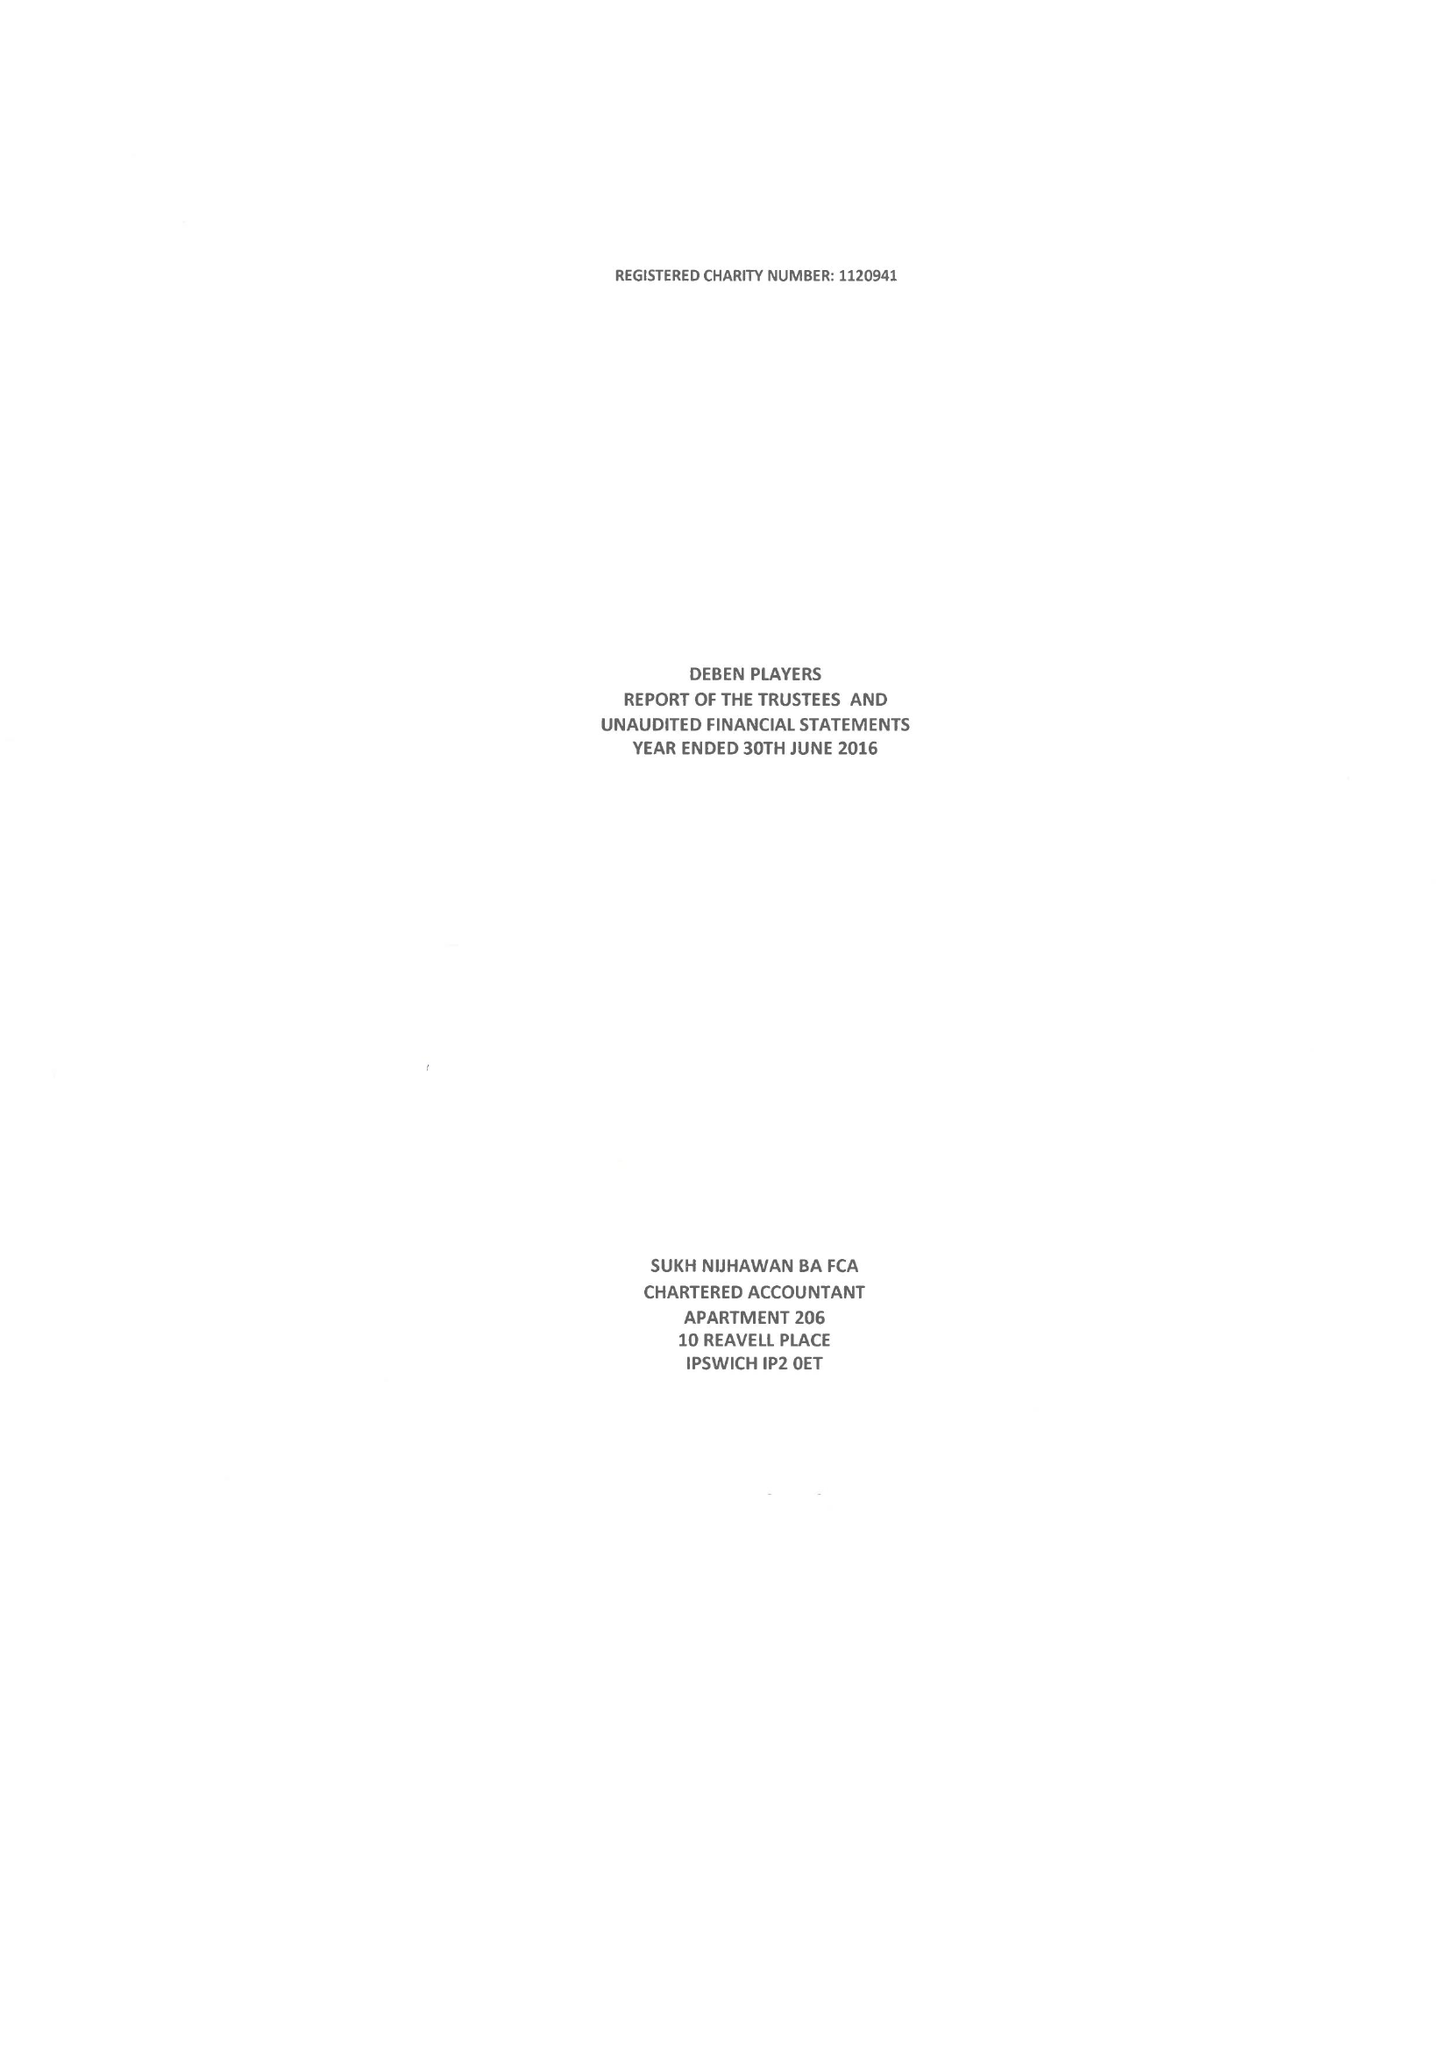What is the value for the address__post_town?
Answer the question using a single word or phrase. FELIXSTOWE 